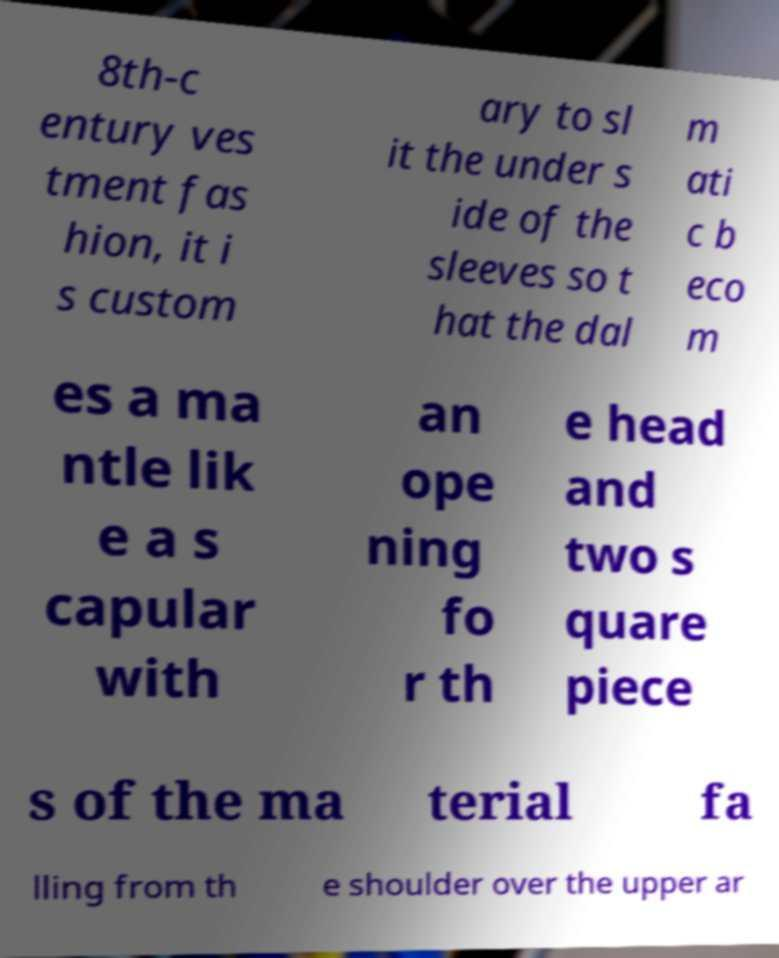Could you assist in decoding the text presented in this image and type it out clearly? 8th-c entury ves tment fas hion, it i s custom ary to sl it the under s ide of the sleeves so t hat the dal m ati c b eco m es a ma ntle lik e a s capular with an ope ning fo r th e head and two s quare piece s of the ma terial fa lling from th e shoulder over the upper ar 